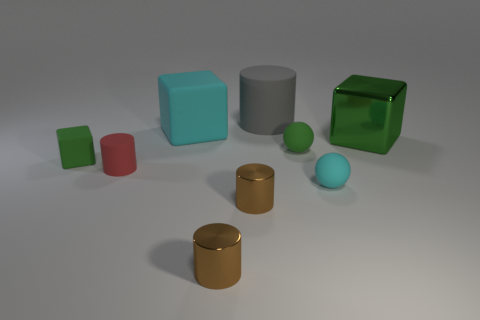Subtract 1 cylinders. How many cylinders are left? 3 Add 1 large brown shiny things. How many objects exist? 10 Subtract all cylinders. How many objects are left? 5 Add 7 big gray matte cylinders. How many big gray matte cylinders exist? 8 Subtract 1 red cylinders. How many objects are left? 8 Subtract all large gray balls. Subtract all cubes. How many objects are left? 6 Add 8 cyan rubber balls. How many cyan rubber balls are left? 9 